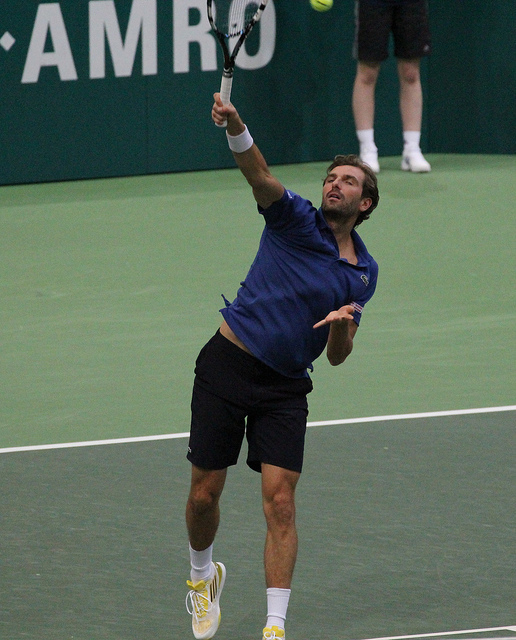Identify the text displayed in this image. AMRO 